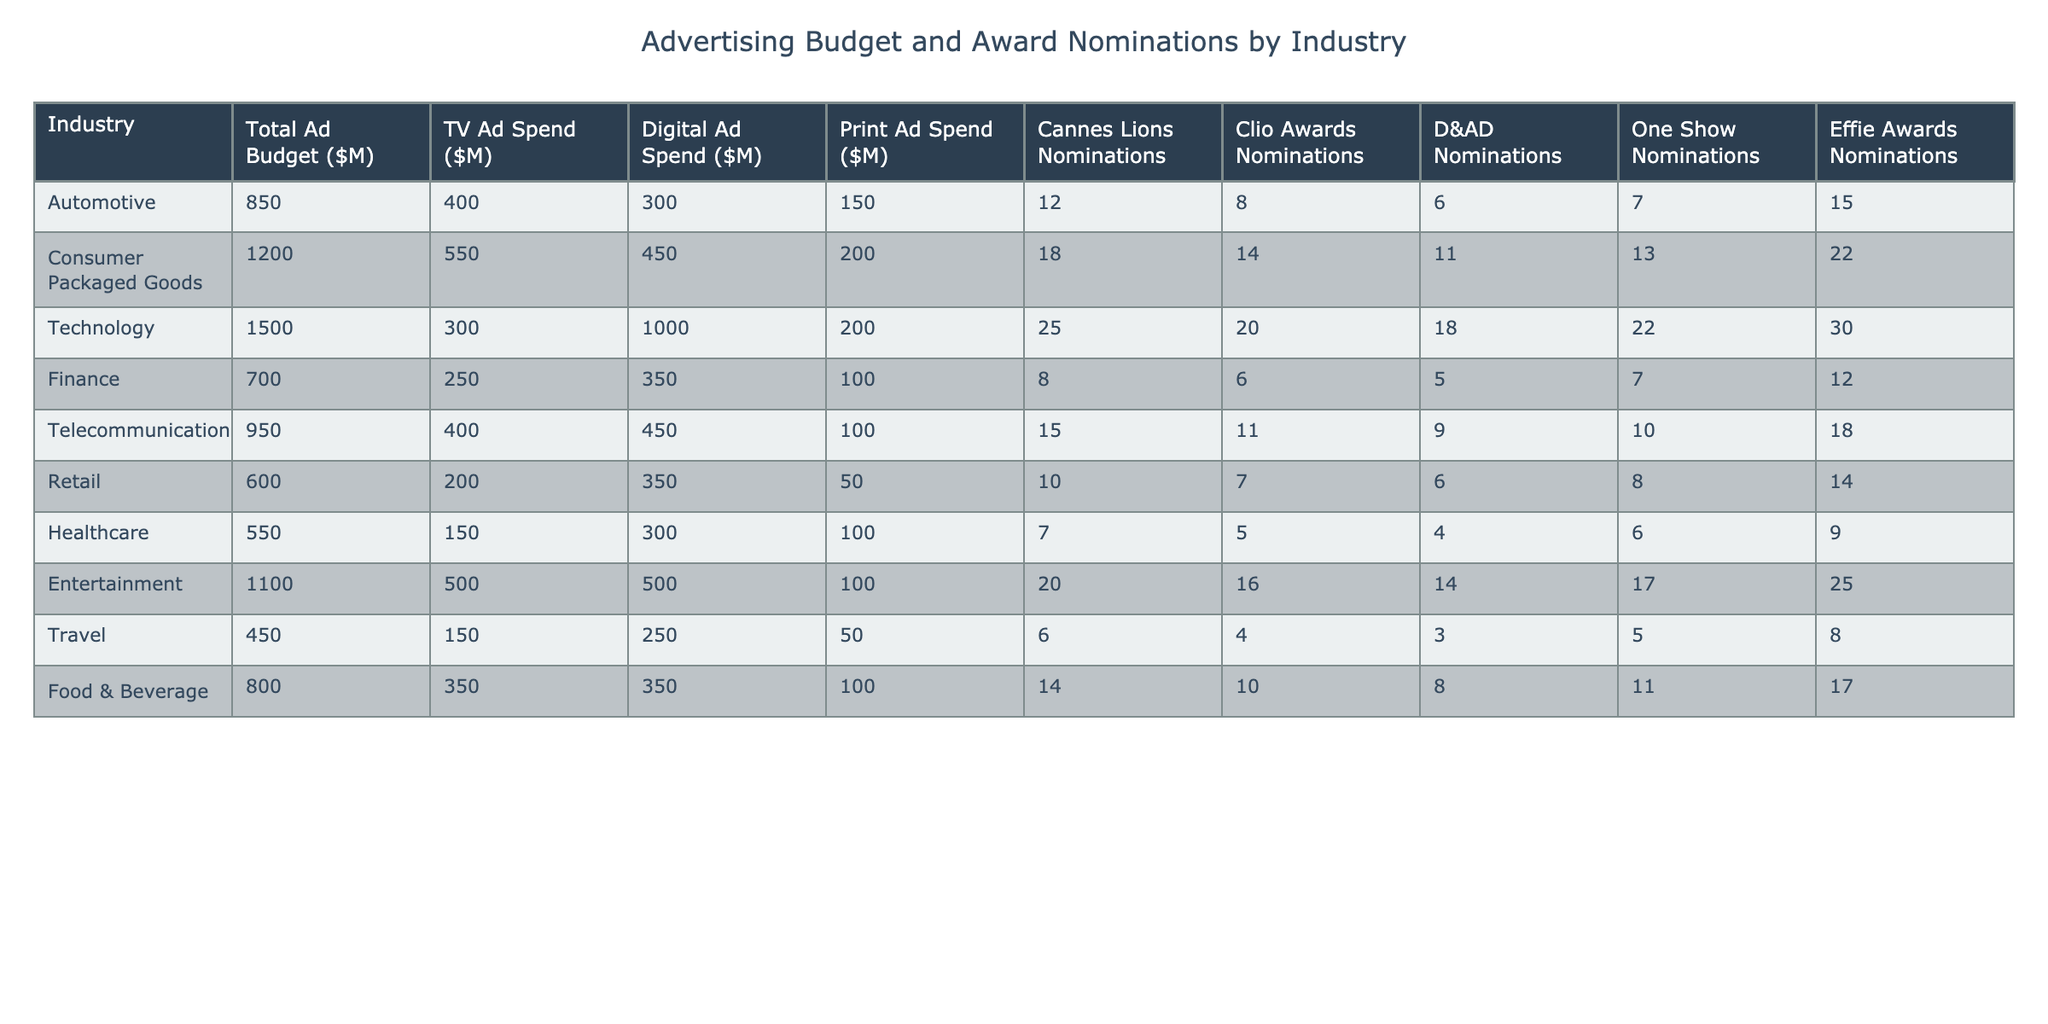What is the total advertising budget for the Technology sector? Referring to the table's Technology row, the value listed under "Total Ad Budget ($M)" is 1500.
Answer: 1500 Which sector has the highest number of Cannes Lions nominations? From the table, the Technology sector has the most Cannes Lions nominations with a count of 25.
Answer: Technology How much does the Healthcare industry's ad spend on Digital ads differ from that of the Automotive industry? The Healthcare industry spent 300 million on Digital ads, while the Automotive industry spent 300 million, so the difference is 0 million.
Answer: 0 million What is the average number of Clio Awards nominations across all sectors? To find the average, sum all Clio Awards nominations (8 + 14 + 20 + 6 + 11 + 7 + 5 + 16 + 4 + 10 =  101) and divide by the number of sectors (10), which gives 101 / 10 = 10.1.
Answer: 10.1 Which industry had the lowest number of Effie Awards nominations, and how many nominations did they receive? Looking at the table, the Travel industry has the lowest Effie Awards nominations with a count of 8.
Answer: Travel, 8 Is it true that the Consumer Packaged Goods sector has more Print Ad Spend than the Finance sector? The Consumer Packaged Goods sector has 200 million in Print Ad Spend, while the Finance sector has 100 million, so the statement is true.
Answer: True What is the difference in total ad budgets between the Automotive and Retail sectors? The Automotive sector has a budget of 850 million, whereas the Retail sector has a budget of 600 million. The difference is 850 - 600 = 250 million.
Answer: 250 million Which sector spends the least on Print ads, and how much do they spend? The Retail sector has the least Print ad spend, with a total of 50 million.
Answer: Retail, 50 million How many more Digital Ad Spend does the Technology sector have compared to the Consumer Packaged Goods sector? The Technology sector has 1000 million on Digital ads, and the Consumer Packaged Goods sector has 450 million. The difference is 1000 - 450 = 550 million.
Answer: 550 million Are there any sectors that received more than 15 nominations across all award types combined? Adding the nominations for each sector, both the Technology (25 + 20 + 18 + 22 + 30) and the Entertainment sector (20 + 16 + 14 + 17 + 25) exceed 15 nominations. Therefore, true.
Answer: True 